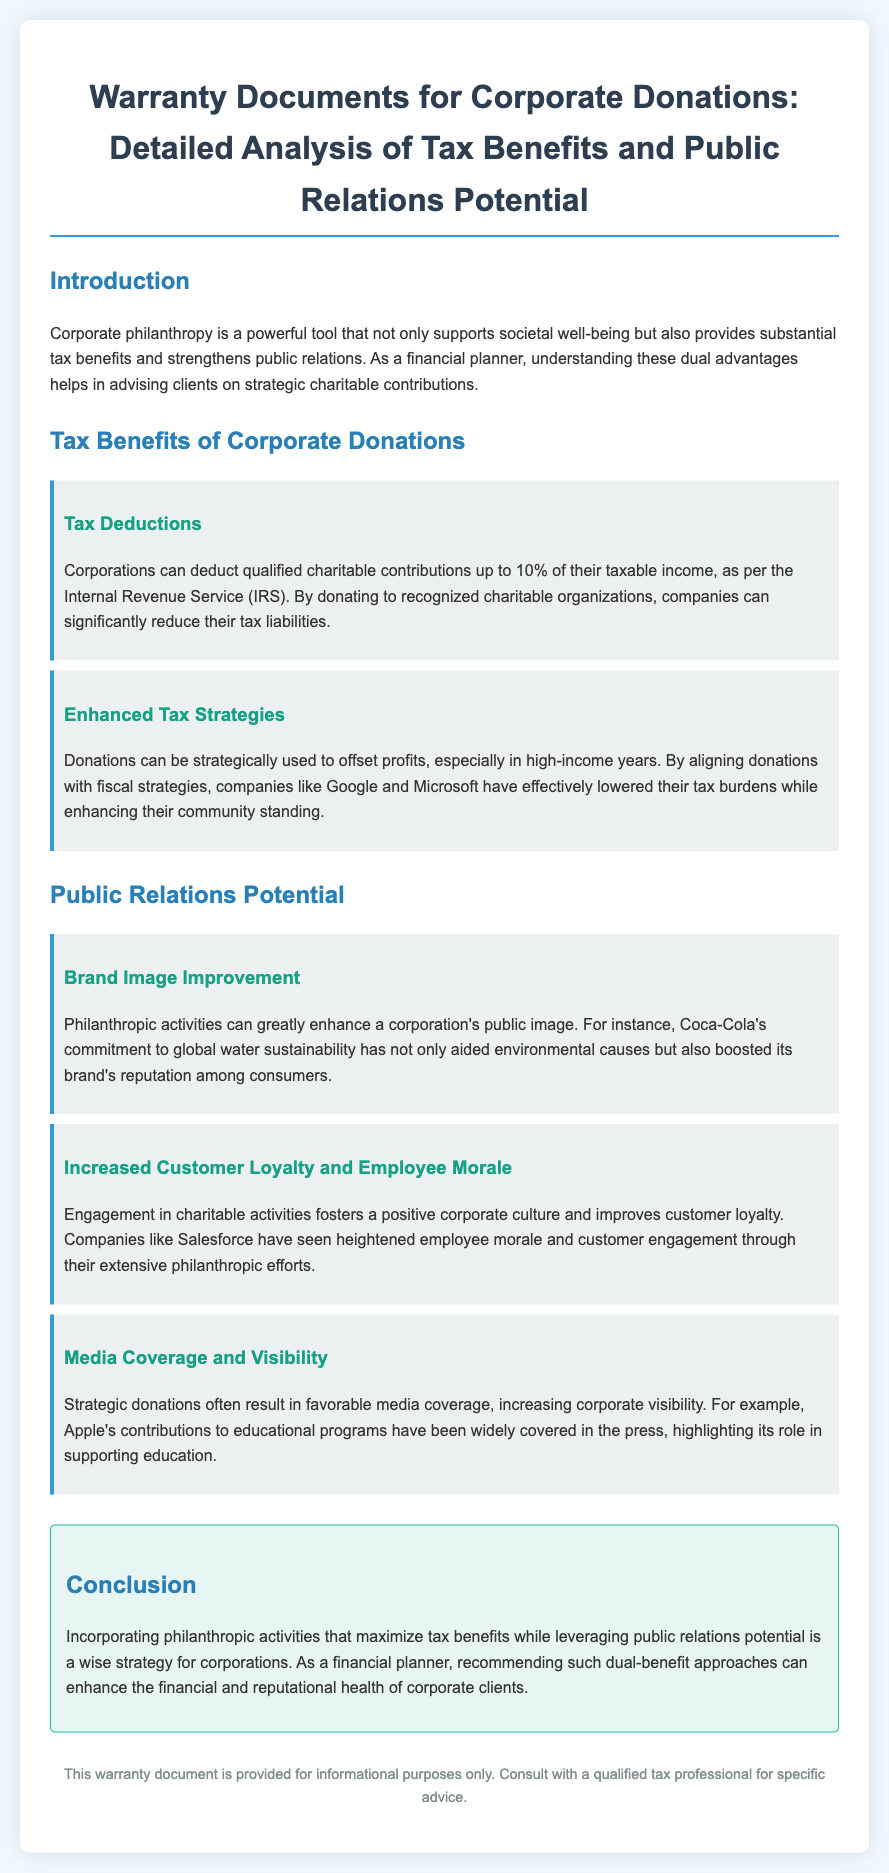What is the maximum tax deduction for corporate donations? The document states that corporations can deduct qualified charitable contributions up to 10% of their taxable income.
Answer: 10% Which company's donations are mentioned in relation to enhanced tax strategies? Google and Microsoft are cited as companies that have strategically used donations to lower their tax burdens.
Answer: Google and Microsoft What type of corporate activity improves brand image according to the document? Philanthropic activities are highlighted as a way to improve a corporation's public image.
Answer: Philanthropic activities What impact do charitable activities have on employee morale? The document mentions that engagement in charitable activities improves employee morale.
Answer: Improves employee morale Which company is noted for its commitment to global water sustainability? Coca-Cola is mentioned as having a commitment to global water sustainability.
Answer: Coca-Cola What effect does media coverage have on corporate visibility? The document states that strategic donations often result in favorable media coverage, increasing corporate visibility.
Answer: Increases corporate visibility What conclusion is drawn about incorporating philanthropic activities? The conclusion emphasizes maximizing tax benefits while leveraging public relations potential.
Answer: Maximize tax benefits while leveraging public relations potential Which company is associated with educational program contributions? Apple is acknowledged for its contributions to educational programs.
Answer: Apple 